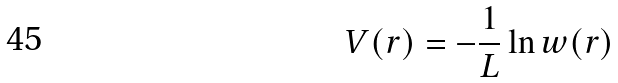Convert formula to latex. <formula><loc_0><loc_0><loc_500><loc_500>V ( r ) = - \frac { 1 } { L } \ln w ( r )</formula> 